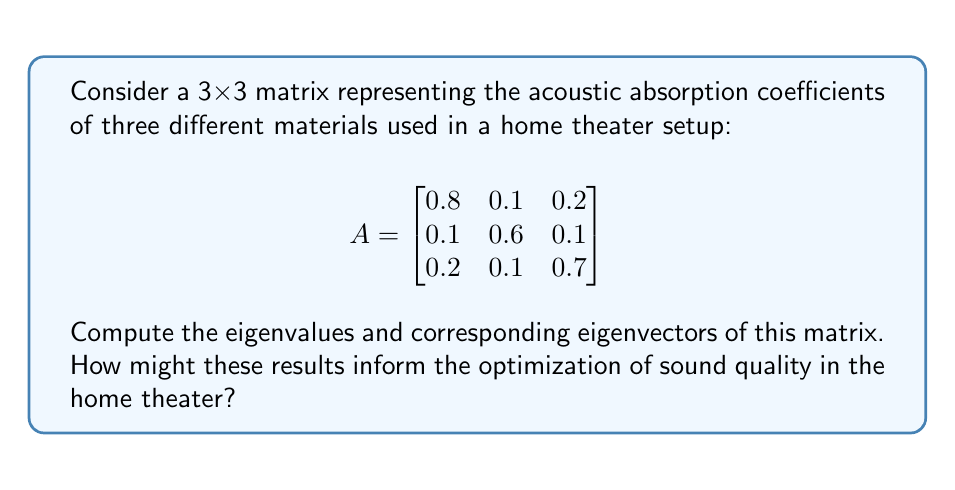Give your solution to this math problem. To find the eigenvalues and eigenvectors of matrix A, we follow these steps:

1. Find the characteristic equation:
   $$det(A - \lambda I) = 0$$
   where $\lambda$ represents the eigenvalues and I is the 3x3 identity matrix.

2. Expand the determinant:
   $$\begin{vmatrix}
   0.8 - \lambda & 0.1 & 0.2 \\
   0.1 & 0.6 - \lambda & 0.1 \\
   0.2 & 0.1 & 0.7 - \lambda
   \end{vmatrix} = 0$$

3. Solve the resulting cubic equation:
   $$(0.8 - \lambda)(0.6 - \lambda)(0.7 - \lambda) - 0.1^2(0.7 - \lambda) - 0.2^2(0.6 - \lambda) - 0.1^2(0.8 - \lambda) + 2(0.1)(0.1)(0.2) = 0$$

   This simplifies to:
   $$-\lambda^3 + 2.1\lambda^2 - 1.41\lambda + 0.3 = 0$$

4. Solve this equation to find the eigenvalues. Using a numerical method or computer algebra system, we get:
   $$\lambda_1 \approx 0.9923, \lambda_2 \approx 0.6881, \lambda_3 \approx 0.4196$$

5. For each eigenvalue, solve $(A - \lambda_i I)\vec{v} = \vec{0}$ to find the corresponding eigenvector.

For $\lambda_1 \approx 0.9923$:
$$\begin{bmatrix}
-0.1923 & 0.1 & 0.2 \\
0.1 & -0.3923 & 0.1 \\
0.2 & 0.1 & -0.2923
\end{bmatrix}\begin{bmatrix}
v_1 \\ v_2 \\ v_3
\end{bmatrix} = \begin{bmatrix}
0 \\ 0 \\ 0
\end{bmatrix}$$

Solving this system gives us the eigenvector:
$$\vec{v}_1 \approx \begin{bmatrix} 0.6742 \\ 0.3371 \\ 0.6572 \end{bmatrix}$$

Similarly, for $\lambda_2 \approx 0.6881$ and $\lambda_3 \approx 0.4196$, we get:
$$\vec{v}_2 \approx \begin{bmatrix} -0.6111 \\ 0.7778 \\ -0.1481 \end{bmatrix}$$
$$\vec{v}_3 \approx \begin{bmatrix} 0.4082 \\ 0.4082 \\ -0.8165 \end{bmatrix}$$

These results can inform the optimization of sound quality in the home theater by:
1. The largest eigenvalue (0.9923) indicates the dominant acoustic absorption mode, which could represent the overall absorption characteristics of the room.
2. The corresponding eigenvector shows the relative contribution of each material to this mode, helping to identify which materials have the most significant impact on sound absorption.
3. The other eigenvalues and eigenvectors represent secondary absorption modes, which could be used to fine-tune the acoustic properties of the space.
4. By analyzing these modes, an acoustics expert can recommend adjustments to material placement or quantities to achieve desired sound quality characteristics.
Answer: Eigenvalues: $\lambda_1 \approx 0.9923, \lambda_2 \approx 0.6881, \lambda_3 \approx 0.4196$

Eigenvectors:
$$\vec{v}_1 \approx \begin{bmatrix} 0.6742 \\ 0.3371 \\ 0.6572 \end{bmatrix}$$
$$\vec{v}_2 \approx \begin{bmatrix} -0.6111 \\ 0.7778 \\ -0.1481 \end{bmatrix}$$
$$\vec{v}_3 \approx \begin{bmatrix} 0.4082 \\ 0.4082 \\ -0.8165 \end{bmatrix}$$ 